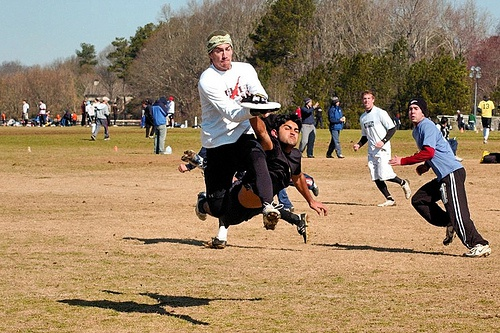Describe the objects in this image and their specific colors. I can see people in lightblue, black, white, darkgray, and gray tones, people in lightblue, black, darkgray, maroon, and white tones, people in lightblue, black, maroon, and salmon tones, people in lightblue, black, gray, tan, and white tones, and people in lightblue, white, black, darkgray, and gray tones in this image. 